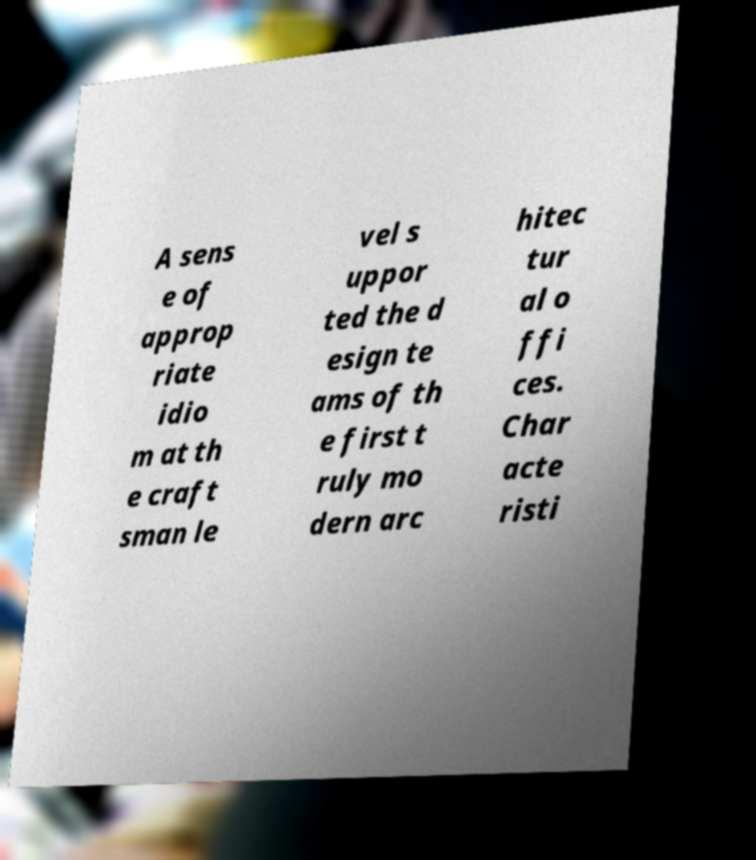Could you extract and type out the text from this image? A sens e of approp riate idio m at th e craft sman le vel s uppor ted the d esign te ams of th e first t ruly mo dern arc hitec tur al o ffi ces. Char acte risti 